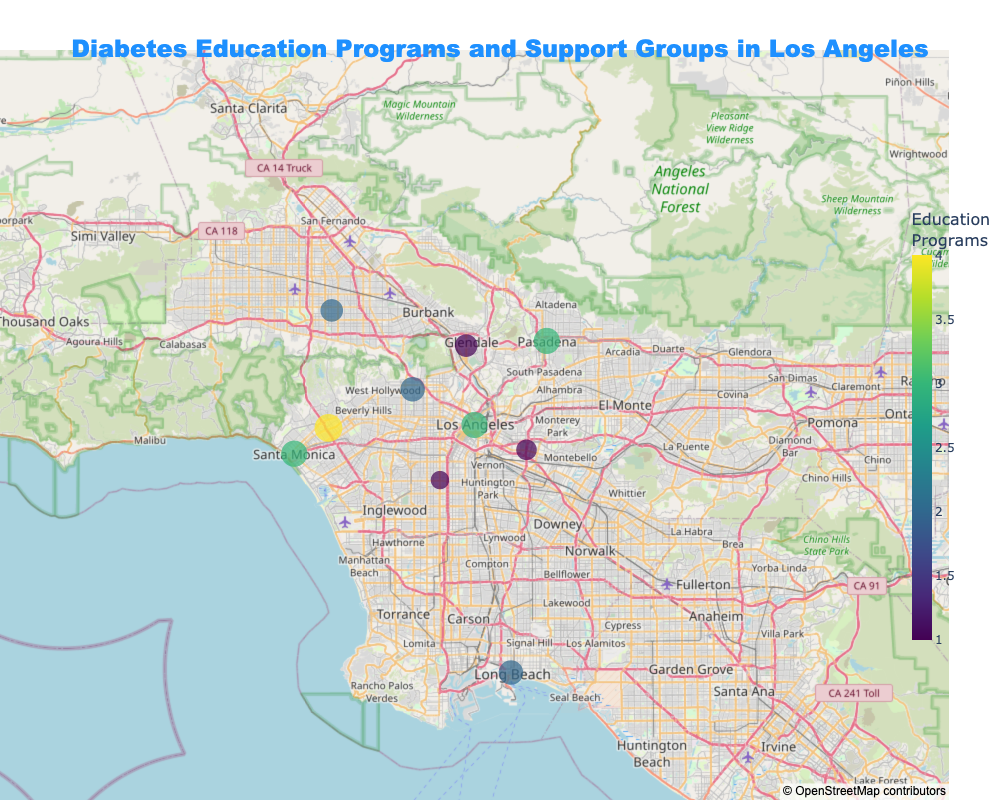What is the title of the figure? The title of the figure is located at the top center. It reads "Diabetes Education Programs and Support Groups in Los Angeles".
Answer: Diabetes Education Programs and Support Groups in Los Angeles Which neighborhood has the highest accessibility score? By looking at the map, the size of the markers represents the Accessibility Score. The neighborhood with the largest marker is Westside, which indicates the highest Accessibility Score.
Answer: Westside How many education programs are available in Downtown? The color of the markers indicates the number of education programs. By focusing on the marker for Downtown, we can check the color which corresponds to the color bar. Downtown has a marker with a count that matches 3 in the color bar.
Answer: 3 Which neighborhood has both 3 education programs and 2 support groups? By examining the hover data displayed for each marker, we can identify which neighborhood has 3 education programs and 2 support groups. This applies to Downtown, Pasadena, and Santa Monica.
Answer: Downtown, Pasadena, and Santa Monica Which neighborhood has the lowest number of support groups and what is its accessibility score? Hover over each marker to check the number of support groups. South Central has the lowest number of support groups (0). Its corresponding marker size indicates an Accessibility Score of 4.
Answer: South Central, 4 How many support groups are there in Pasadena? Hover over the marker representing Pasadena. The information displayed shows that there are 2 support groups in Pasadena.
Answer: 2 What is the difference in the number of education programs between Westside and East Los Angeles? Westside has 4 education programs while East Los Angeles has 1. The difference is calculated as 4 - 1.
Answer: 3 Which neighborhood has more education programs: Hollywood or Glendale? By comparing the markers for Hollywood and Glendale, we see that Hollywood has 2 education programs while Glendale has 1. Hollywood has more education programs.
Answer: Hollywood What is the total number of support groups in neighborhoods with an accessibility score of 8? The neighborhoods with an accessibility score of 8 are Downtown, Pasadena, and Santa Monica. They have 2, 2, and 2 support groups respectively. Summing them up gives 2 + 2 + 2.
Answer: 6 Which neighborhoods have the same number of education programs, and how many do they have? By looking at the colors of the markers, we can identify neighborhoods with the same color. Hollywood and San Fernando Valley both have 2 education programs.
Answer: Hollywood and San Fernando Valley, 2 